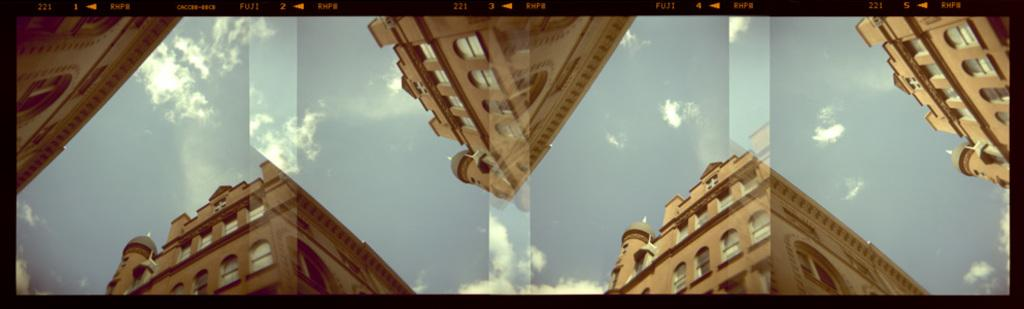What can be observed about the image that suggests it has been edited? The image appears to be edited, but the specific editing techniques or effects are not mentioned in the facts. What type of structures are visible in the image? There are buildings with windows in the image. What can be seen in the sky in the image? There are clouds in the sky in the image. What is the taste of the basin in the image? There is no basin present in the image, and therefore no taste can be associated with it. 